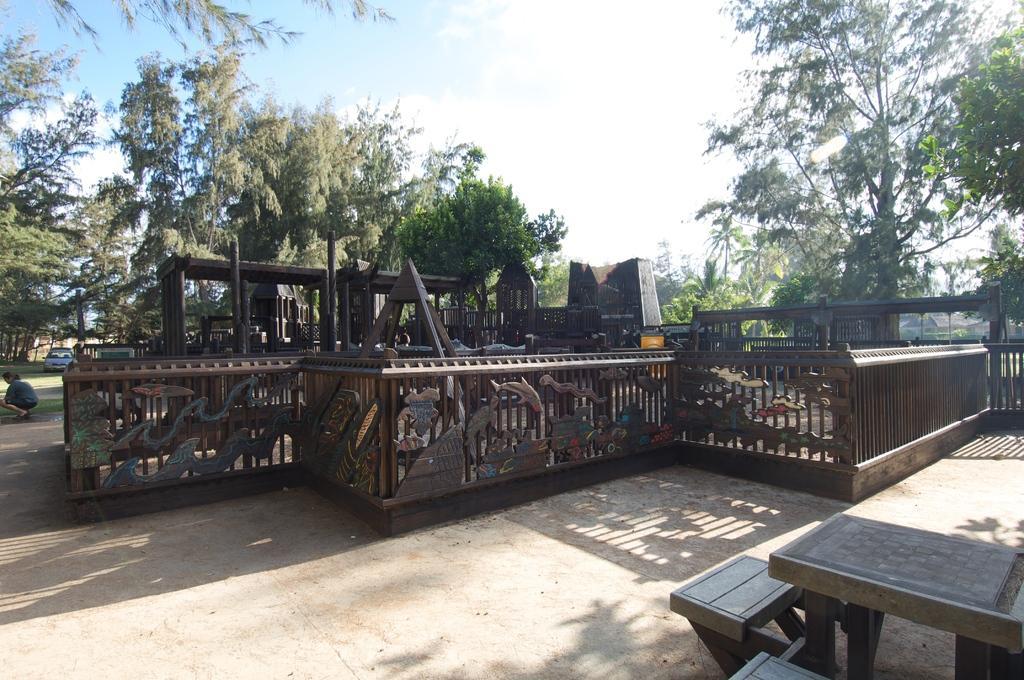In one or two sentences, can you explain what this image depicts? In this image there is a metal railing, in the background there are metal objects, trees, car and the sky, in the bottom right there is a table and chairs. 